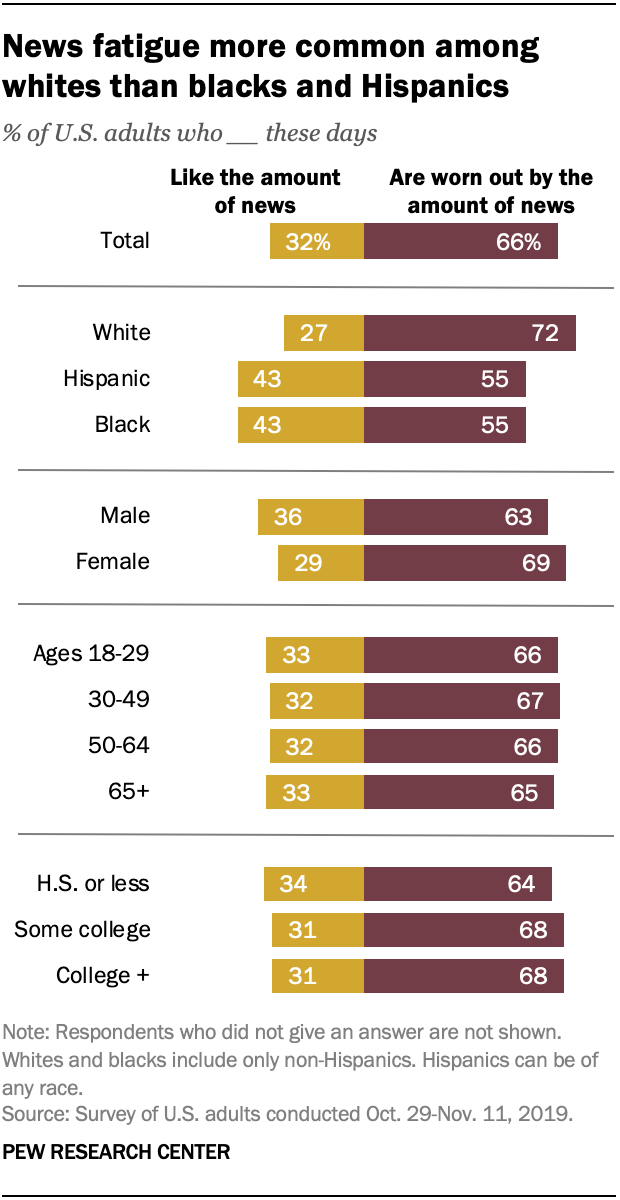Indicate a few pertinent items in this graphic. The largest value of the purple bar is 72. The value of purple bars is always greater than that of yellow bars. 